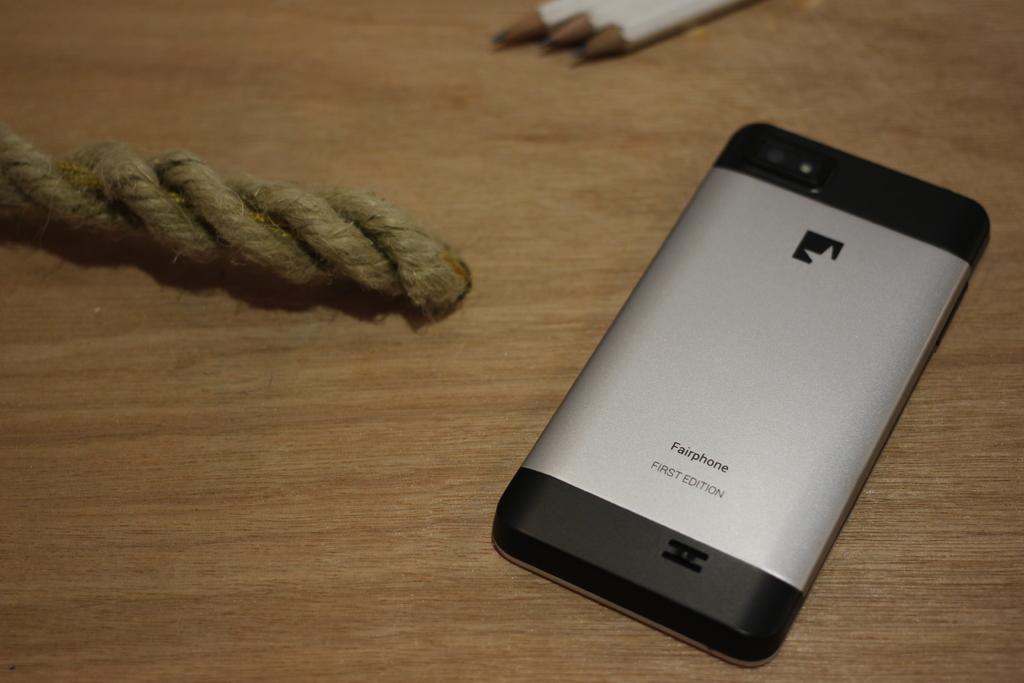What brand phone is that?
Make the answer very short. Fairphone. What edition phone is this?
Provide a succinct answer. First. 